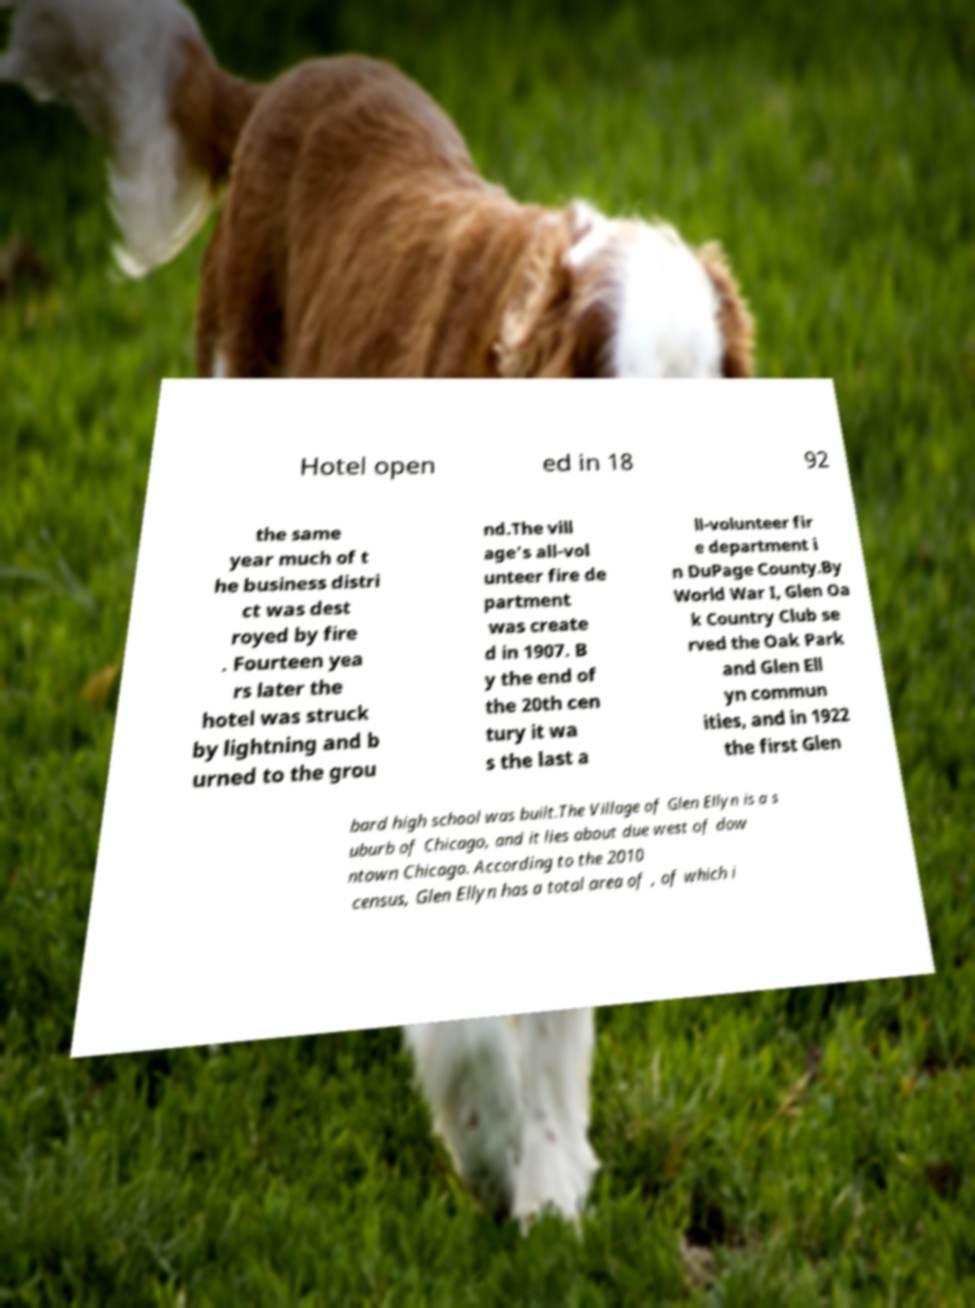I need the written content from this picture converted into text. Can you do that? Hotel open ed in 18 92 the same year much of t he business distri ct was dest royed by fire . Fourteen yea rs later the hotel was struck by lightning and b urned to the grou nd.The vill age's all-vol unteer fire de partment was create d in 1907. B y the end of the 20th cen tury it wa s the last a ll-volunteer fir e department i n DuPage County.By World War I, Glen Oa k Country Club se rved the Oak Park and Glen Ell yn commun ities, and in 1922 the first Glen bard high school was built.The Village of Glen Ellyn is a s uburb of Chicago, and it lies about due west of dow ntown Chicago. According to the 2010 census, Glen Ellyn has a total area of , of which i 